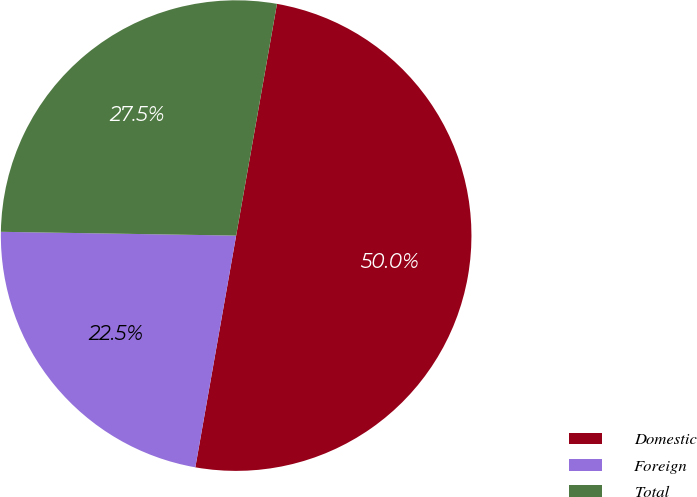<chart> <loc_0><loc_0><loc_500><loc_500><pie_chart><fcel>Domestic<fcel>Foreign<fcel>Total<nl><fcel>50.0%<fcel>22.48%<fcel>27.52%<nl></chart> 